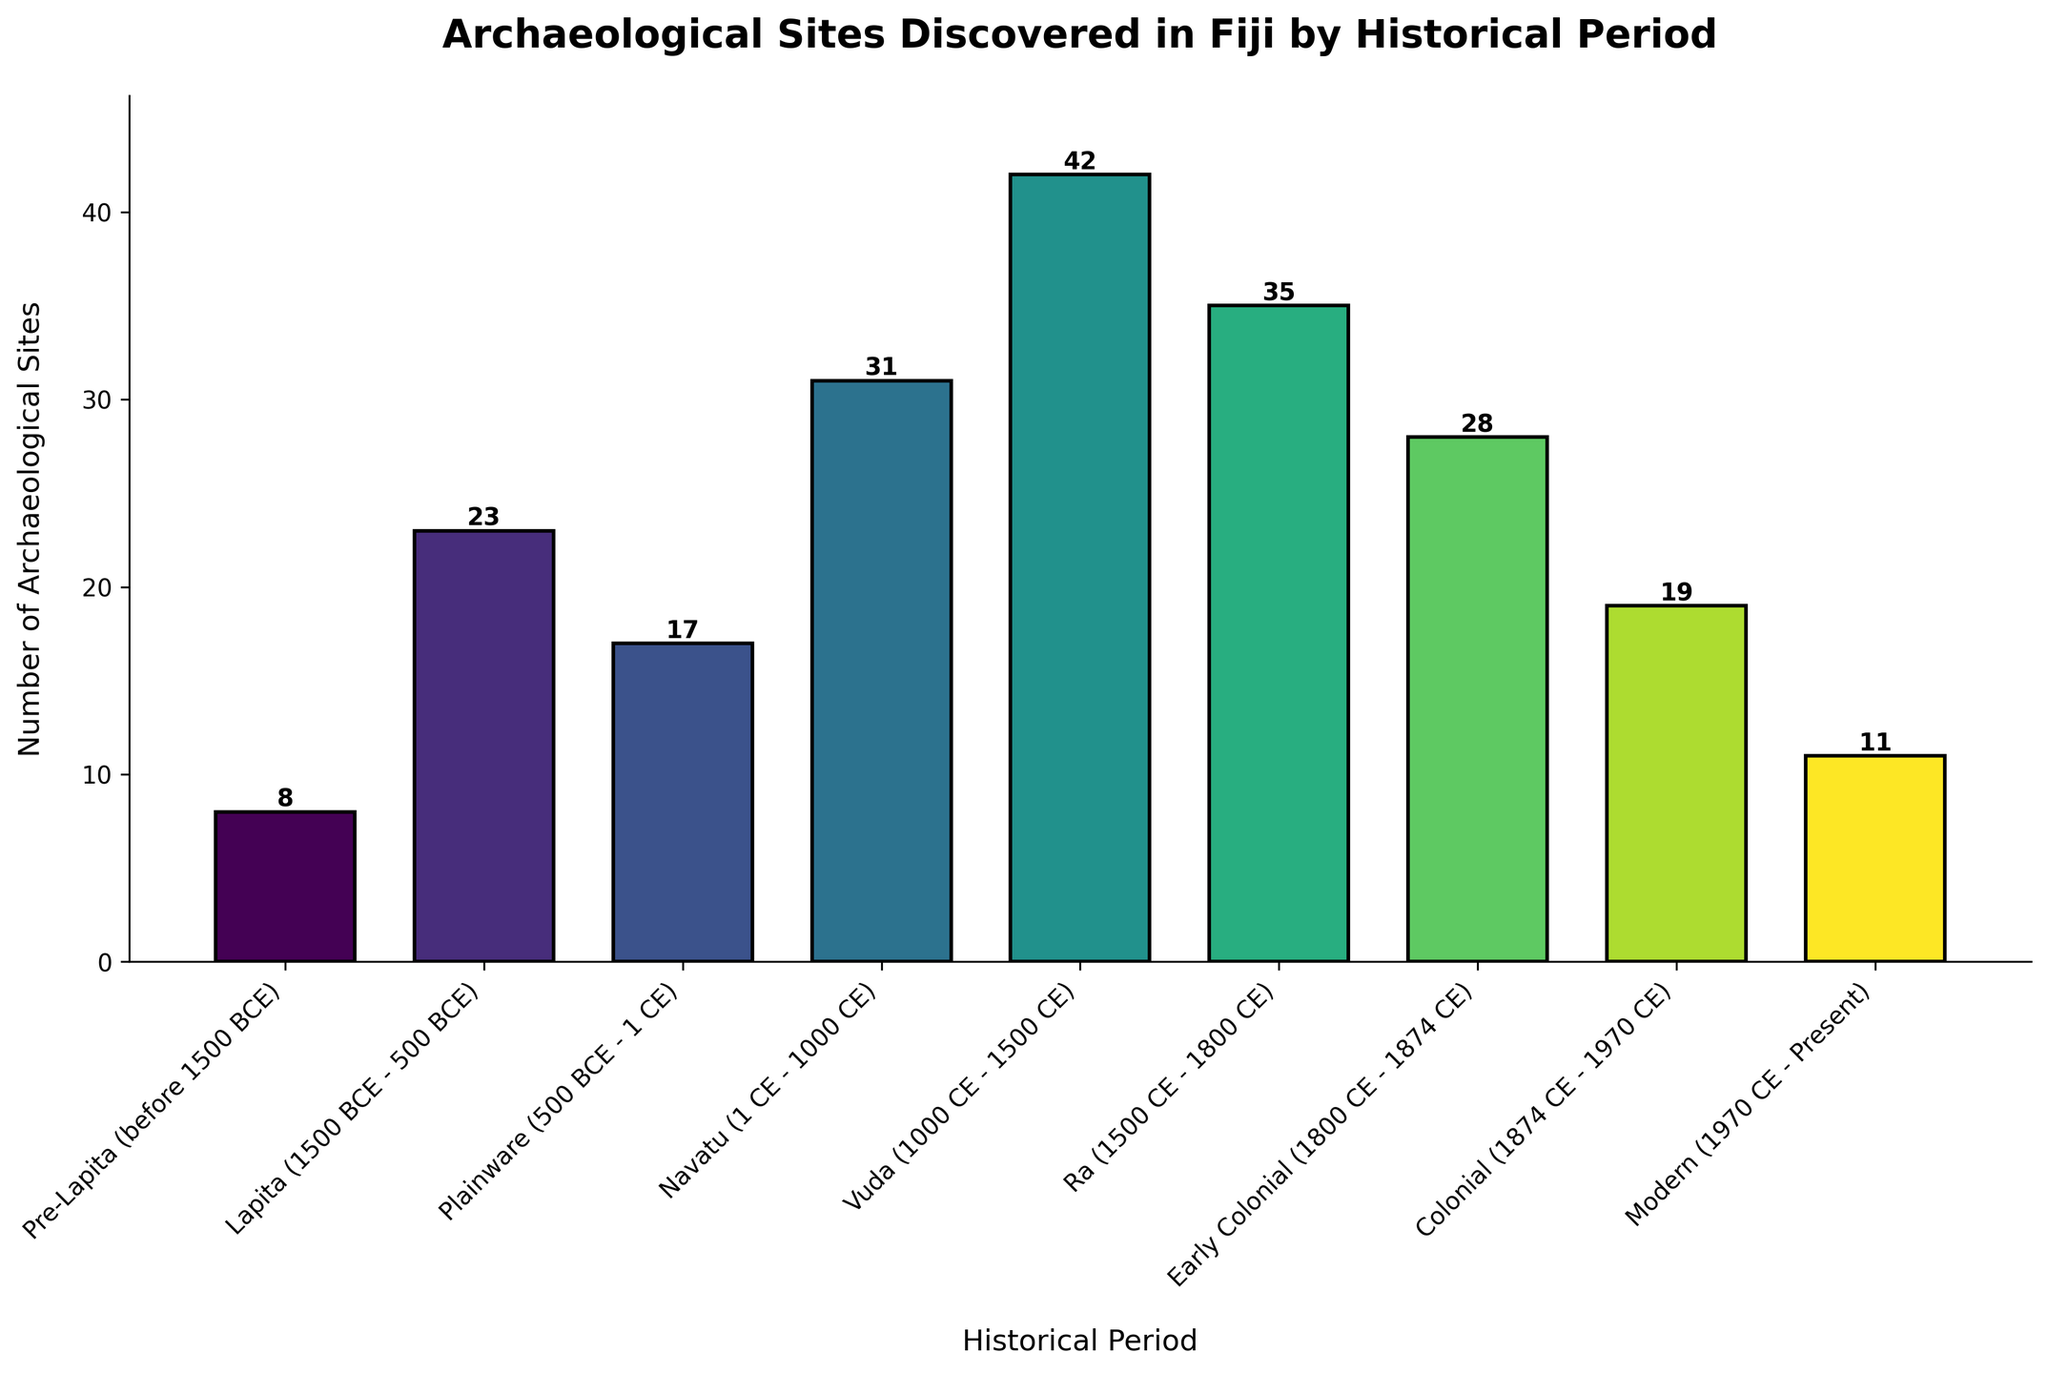What is the historical period with the highest number of archaeological sites? Look at the bar that is the tallest. The historical period indicated by the tallest bar is Vuda.
Answer: Vuda Which historical period discovered in Fiji has the lowest number of archaeological sites? Look for the shortest bar in the chart. The historical period for the shortest bar is Pre-Lapita.
Answer: Pre-Lapita How many more archaeological sites were discovered in the Ra period compared to the Plainware period? Subtract the number of archaeological sites in the Plainware period from the number of sites in the Ra period: 35 (Ra) - 17 (Plainware) = 18.
Answer: 18 What is the average number of archaeological sites discovered in the Lapita, Plainware, and Navatu periods combined? First, sum the number of archaeological sites in the Lapita, Plainware, and Navatu periods: 23 (Lapita) + 17 (Plainware) + 31 (Navatu) = 71. Then, divide by 3 (for the three periods): 71 / 3 = 23.67.
Answer: 23.67 Which period had more archaeological sites, the Colonial or the Early Colonial? Compare the heights of the bars for the Colonial and Early Colonial periods. The Early Colonial period's bar is taller than the Colonial period's. Early Colonial had 28 sites, and Colonial had 19 sites.
Answer: Early Colonial What is the total number of archaeological sites discovered across all periods? Sum the number of archaeological sites for all periods: 8 + 23 + 17 + 31 + 42 + 35 + 28 + 19 + 11 = 214.
Answer: 214 Between which periods is there the greatest increase in the number of archaeological sites discovered? Look for the largest difference in height between two consecutive bars. The greatest increase is from Pre-Lapita (8) to Lapita (23), an increase of 15.
Answer: Pre-Lapita to Lapita What is the difference in the number of archaeological sites between the Early Colonial and Modern periods? Subtract the number of archaeological sites in the Modern period from the Early Colonial period: 28 (Early Colonial) - 11 (Modern) = 17.
Answer: 17 What is the median value of the number of archaeological sites discovered across all periods? First, list the numbers in ascending order: 8, 11, 17, 19, 23, 28, 31, 35, 42. The median value is the middle number in this ordered list, which is 23.
Answer: 23 During which periods were there fewer than 20 archaeological sites discovered? Identify the periods with bars shorter than the height corresponding to 20 sites: Pre-Lapita (8), Plainware (17), Colonial (19), Modern (11).
Answer: Pre-Lapita, Plainware, Colonial, Modern 